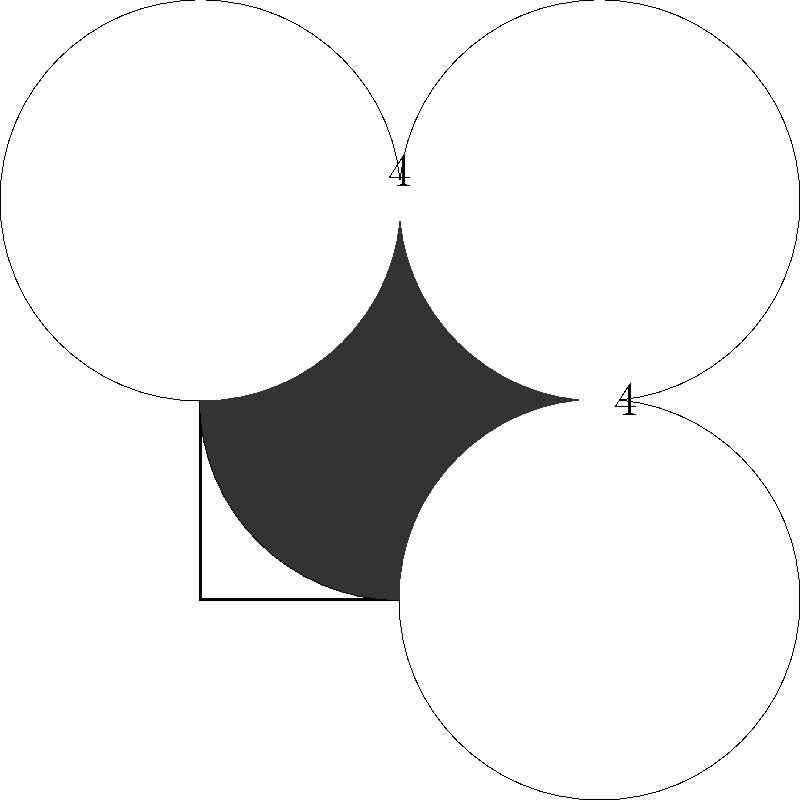In a mock interview scenario, you're presented with a square diagram representing a potential office layout. The square has a side length of 4 units, and four circular areas represent different workspaces, each centered at a corner of the square with a radius of 2 units. What is the area of the shaded region in the center, which represents a common area not covered by any of the workspaces? Let's approach this step-by-step:

1) The area of the entire square is:
   $A_{square} = 4^2 = 16$ square units

2) Each circle has a radius of 2 units, so its area is:
   $A_{circle} = \pi r^2 = \pi (2^2) = 4\pi$ square units

3) The total area of the four circles is:
   $A_{total circles} = 4 \times 4\pi = 16\pi$ square units

4) However, these circles overlap. The overlapping parts are counted multiple times in our calculation.

5) The overlapping parts form four equal "lenses" at the corners of the square. Each lens is formed by the intersection of two circles.

6) The area of each lens can be calculated using the formula:
   $A_{lens} = 2r^2 \arccos(\frac{d}{2r}) - d\sqrt{r^2 - (\frac{d}{2})^2}$
   where $r$ is the radius of the circles and $d$ is the distance between their centers.

7) In this case, $r = 2$ and $d = 4$ (the diagonal of the square):
   $A_{lens} = 2(2^2) \arccos(\frac{4}{2(2)}) - 4\sqrt{2^2 - 2^2} = 8 \arccos(\frac{1}{2}) - 4\sqrt{0} = 8 \arccos(0.5)$

8) The total area of the four lenses is:
   $A_{total lenses} = 4 \times 8 \arccos(0.5) = 32 \arccos(0.5)$

9) Therefore, the actual area covered by the circles is:
   $A_{covered} = 16\pi - 32 \arccos(0.5)$

10) Finally, the shaded area (the area not covered by the circles) is:
    $A_{shaded} = A_{square} - A_{covered} = 16 - (16\pi - 32 \arccos(0.5))$
    $= 16 - 16\pi + 32 \arccos(0.5)$
    $= 16(1 - \pi) + 32 \arccos(0.5)$

This is the exact answer. For a numerical approximation, we can calculate:
$16(1 - \pi) + 32 \arccos(0.5) \approx 0.5858$ square units
Answer: $16(1 - \pi) + 32 \arccos(0.5)$ square units 